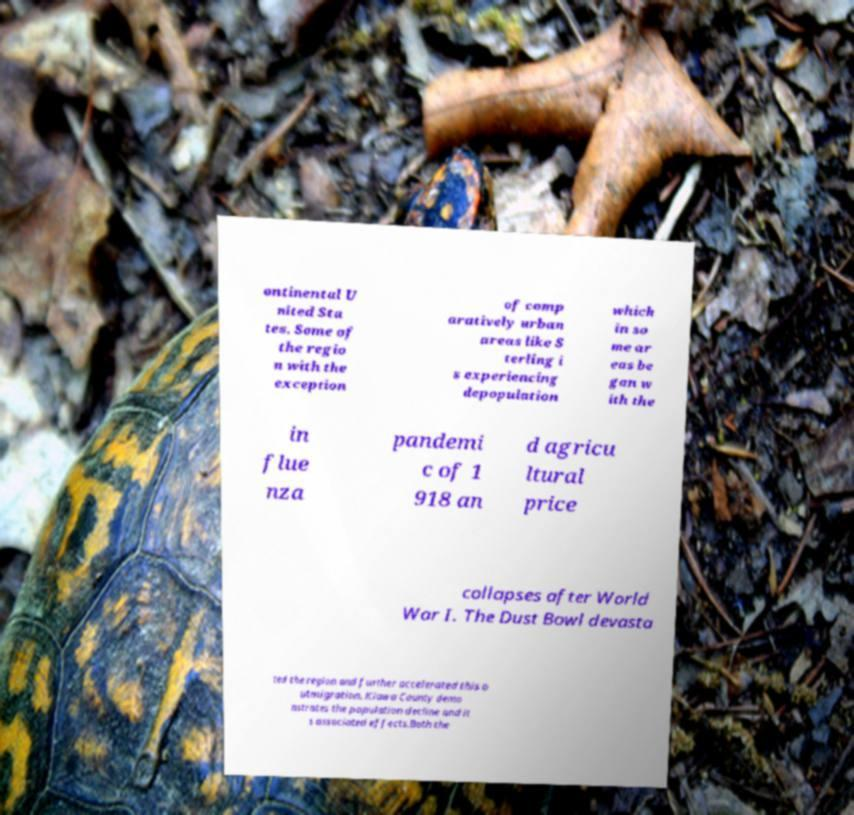Can you accurately transcribe the text from the provided image for me? ontinental U nited Sta tes. Some of the regio n with the exception of comp aratively urban areas like S terling i s experiencing depopulation which in so me ar eas be gan w ith the in flue nza pandemi c of 1 918 an d agricu ltural price collapses after World War I. The Dust Bowl devasta ted the region and further accelerated this o utmigration. Kiowa County demo nstrates the population decline and it s associated effects.Both the 